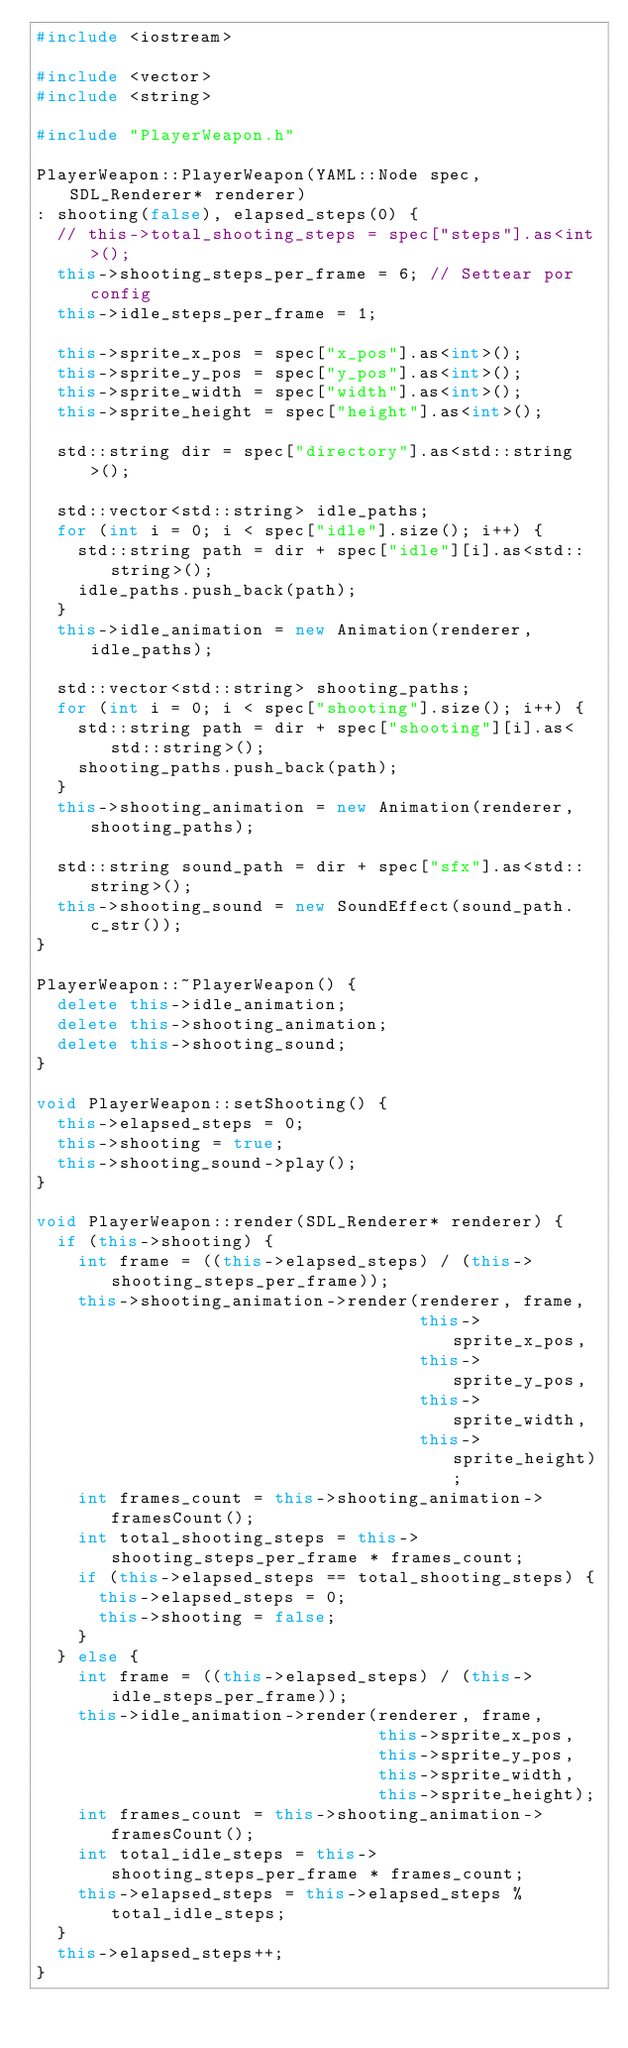<code> <loc_0><loc_0><loc_500><loc_500><_C++_>#include <iostream>

#include <vector>
#include <string>

#include "PlayerWeapon.h"

PlayerWeapon::PlayerWeapon(YAML::Node spec, SDL_Renderer* renderer) 
: shooting(false), elapsed_steps(0) {
  // this->total_shooting_steps = spec["steps"].as<int>();
  this->shooting_steps_per_frame = 6; // Settear por config
  this->idle_steps_per_frame = 1;

  this->sprite_x_pos = spec["x_pos"].as<int>();
  this->sprite_y_pos = spec["y_pos"].as<int>();
  this->sprite_width = spec["width"].as<int>();
  this->sprite_height = spec["height"].as<int>();

  std::string dir = spec["directory"].as<std::string>();

  std::vector<std::string> idle_paths;
  for (int i = 0; i < spec["idle"].size(); i++) {
    std::string path = dir + spec["idle"][i].as<std::string>();
    idle_paths.push_back(path);
  }
  this->idle_animation = new Animation(renderer, idle_paths);

  std::vector<std::string> shooting_paths;
  for (int i = 0; i < spec["shooting"].size(); i++) {
    std::string path = dir + spec["shooting"][i].as<std::string>();
    shooting_paths.push_back(path);
  }
  this->shooting_animation = new Animation(renderer, shooting_paths);

  std::string sound_path = dir + spec["sfx"].as<std::string>();
  this->shooting_sound = new SoundEffect(sound_path.c_str());
}

PlayerWeapon::~PlayerWeapon() {
  delete this->idle_animation;
  delete this->shooting_animation;
  delete this->shooting_sound;
}

void PlayerWeapon::setShooting() {
  this->elapsed_steps = 0;
  this->shooting = true;
  this->shooting_sound->play();
}

void PlayerWeapon::render(SDL_Renderer* renderer) {
  if (this->shooting) {
    int frame = ((this->elapsed_steps) / (this->shooting_steps_per_frame));
    this->shooting_animation->render(renderer, frame,
                                     this->sprite_x_pos, 
                                     this->sprite_y_pos,
                                     this->sprite_width,
                                     this->sprite_height);
    int frames_count = this->shooting_animation->framesCount();
    int total_shooting_steps = this->shooting_steps_per_frame * frames_count;
    if (this->elapsed_steps == total_shooting_steps) {
      this->elapsed_steps = 0;
      this->shooting = false;
    }
  } else {
    int frame = ((this->elapsed_steps) / (this->idle_steps_per_frame));
    this->idle_animation->render(renderer, frame,
                                 this->sprite_x_pos, 
                                 this->sprite_y_pos,
                                 this->sprite_width,
                                 this->sprite_height);
    int frames_count = this->shooting_animation->framesCount();
    int total_idle_steps = this->shooting_steps_per_frame * frames_count;
    this->elapsed_steps = this->elapsed_steps % total_idle_steps;
  }
  this->elapsed_steps++;
}
</code> 